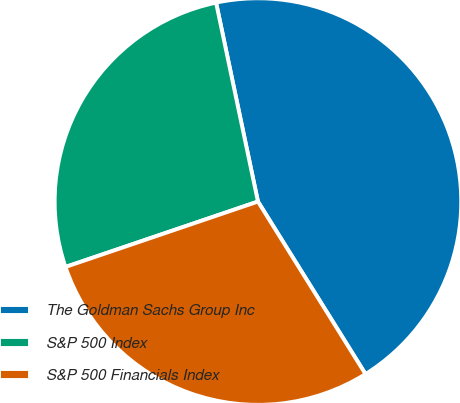Convert chart. <chart><loc_0><loc_0><loc_500><loc_500><pie_chart><fcel>The Goldman Sachs Group Inc<fcel>S&P 500 Index<fcel>S&P 500 Financials Index<nl><fcel>44.43%<fcel>26.91%<fcel>28.66%<nl></chart> 